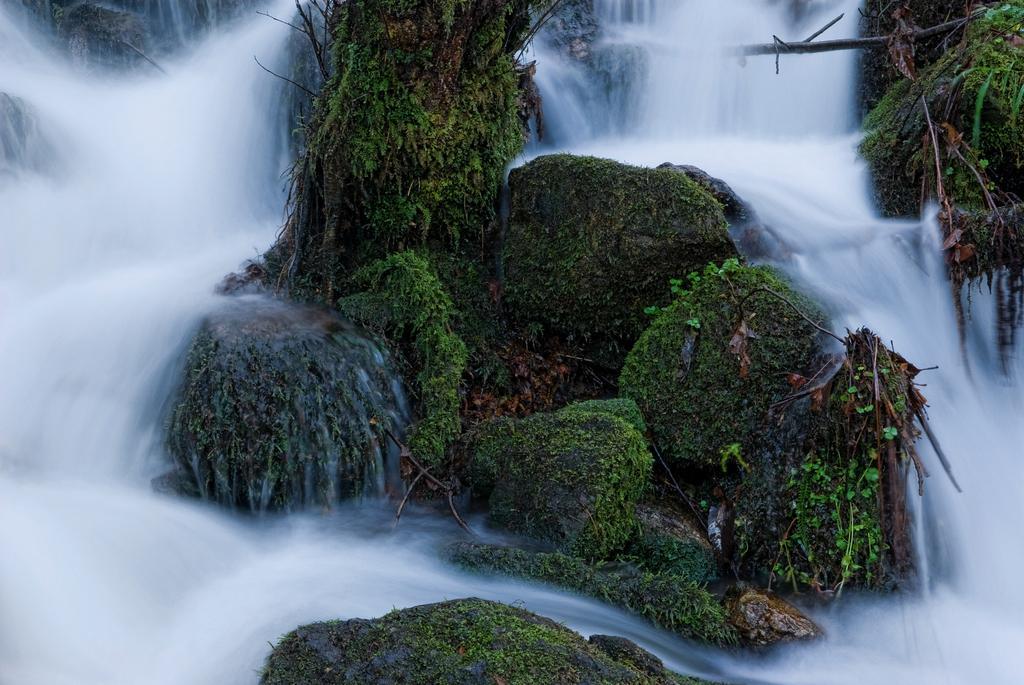In one or two sentences, can you explain what this image depicts? Here in this picture we can see water flowing through a place and in the front we can see rock stones present, that are covered with some plants and algae. 